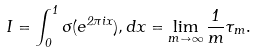Convert formula to latex. <formula><loc_0><loc_0><loc_500><loc_500>I = \int _ { 0 } ^ { 1 } \sigma ( e ^ { 2 \pi i x } ) , d x = \lim _ { m \to \infty } \frac { 1 } { m } \tau _ { m } .</formula> 